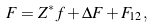Convert formula to latex. <formula><loc_0><loc_0><loc_500><loc_500>F = Z ^ { * } f + \Delta F + F _ { 1 2 } ,</formula> 